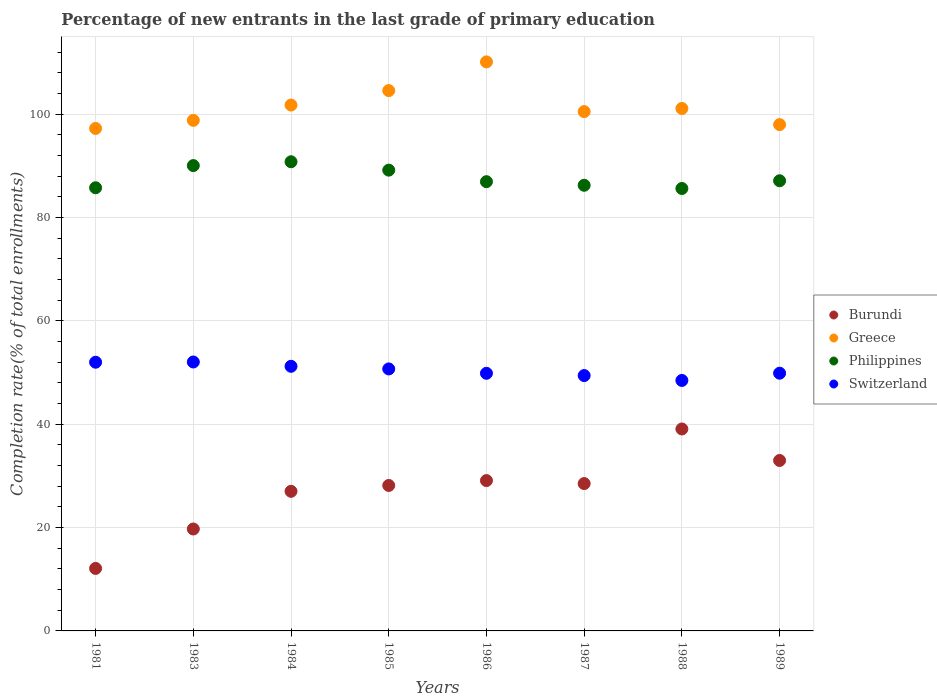Is the number of dotlines equal to the number of legend labels?
Keep it short and to the point. Yes. What is the percentage of new entrants in Philippines in 1985?
Keep it short and to the point. 89.16. Across all years, what is the maximum percentage of new entrants in Burundi?
Make the answer very short. 39.08. Across all years, what is the minimum percentage of new entrants in Philippines?
Provide a short and direct response. 85.61. In which year was the percentage of new entrants in Burundi minimum?
Ensure brevity in your answer.  1981. What is the total percentage of new entrants in Philippines in the graph?
Your answer should be very brief. 701.64. What is the difference between the percentage of new entrants in Switzerland in 1984 and that in 1986?
Provide a short and direct response. 1.35. What is the difference between the percentage of new entrants in Greece in 1985 and the percentage of new entrants in Philippines in 1987?
Your response must be concise. 18.32. What is the average percentage of new entrants in Burundi per year?
Your answer should be compact. 27.08. In the year 1988, what is the difference between the percentage of new entrants in Greece and percentage of new entrants in Philippines?
Provide a succinct answer. 15.48. What is the ratio of the percentage of new entrants in Greece in 1985 to that in 1987?
Provide a short and direct response. 1.04. Is the difference between the percentage of new entrants in Greece in 1984 and 1985 greater than the difference between the percentage of new entrants in Philippines in 1984 and 1985?
Your answer should be very brief. No. What is the difference between the highest and the second highest percentage of new entrants in Burundi?
Provide a succinct answer. 6.09. What is the difference between the highest and the lowest percentage of new entrants in Philippines?
Keep it short and to the point. 5.17. In how many years, is the percentage of new entrants in Philippines greater than the average percentage of new entrants in Philippines taken over all years?
Offer a terse response. 3. Is the sum of the percentage of new entrants in Greece in 1983 and 1989 greater than the maximum percentage of new entrants in Switzerland across all years?
Your response must be concise. Yes. Is it the case that in every year, the sum of the percentage of new entrants in Philippines and percentage of new entrants in Switzerland  is greater than the sum of percentage of new entrants in Greece and percentage of new entrants in Burundi?
Your response must be concise. No. Is it the case that in every year, the sum of the percentage of new entrants in Burundi and percentage of new entrants in Switzerland  is greater than the percentage of new entrants in Philippines?
Provide a succinct answer. No. Does the percentage of new entrants in Switzerland monotonically increase over the years?
Ensure brevity in your answer.  No. What is the difference between two consecutive major ticks on the Y-axis?
Provide a short and direct response. 20. Are the values on the major ticks of Y-axis written in scientific E-notation?
Keep it short and to the point. No. Does the graph contain grids?
Offer a very short reply. Yes. Where does the legend appear in the graph?
Provide a succinct answer. Center right. How many legend labels are there?
Your response must be concise. 4. How are the legend labels stacked?
Ensure brevity in your answer.  Vertical. What is the title of the graph?
Keep it short and to the point. Percentage of new entrants in the last grade of primary education. Does "Honduras" appear as one of the legend labels in the graph?
Provide a succinct answer. No. What is the label or title of the Y-axis?
Your response must be concise. Completion rate(% of total enrollments). What is the Completion rate(% of total enrollments) of Burundi in 1981?
Provide a succinct answer. 12.09. What is the Completion rate(% of total enrollments) of Greece in 1981?
Offer a very short reply. 97.23. What is the Completion rate(% of total enrollments) of Philippines in 1981?
Keep it short and to the point. 85.75. What is the Completion rate(% of total enrollments) in Switzerland in 1981?
Offer a very short reply. 52. What is the Completion rate(% of total enrollments) of Burundi in 1983?
Your answer should be compact. 19.72. What is the Completion rate(% of total enrollments) in Greece in 1983?
Keep it short and to the point. 98.8. What is the Completion rate(% of total enrollments) in Philippines in 1983?
Give a very brief answer. 90.04. What is the Completion rate(% of total enrollments) of Switzerland in 1983?
Keep it short and to the point. 52.04. What is the Completion rate(% of total enrollments) in Burundi in 1984?
Offer a terse response. 27.01. What is the Completion rate(% of total enrollments) in Greece in 1984?
Your answer should be very brief. 101.76. What is the Completion rate(% of total enrollments) in Philippines in 1984?
Provide a short and direct response. 90.79. What is the Completion rate(% of total enrollments) of Switzerland in 1984?
Provide a short and direct response. 51.21. What is the Completion rate(% of total enrollments) in Burundi in 1985?
Provide a succinct answer. 28.15. What is the Completion rate(% of total enrollments) of Greece in 1985?
Make the answer very short. 104.56. What is the Completion rate(% of total enrollments) in Philippines in 1985?
Your answer should be very brief. 89.16. What is the Completion rate(% of total enrollments) in Switzerland in 1985?
Offer a very short reply. 50.7. What is the Completion rate(% of total enrollments) in Burundi in 1986?
Your response must be concise. 29.09. What is the Completion rate(% of total enrollments) in Greece in 1986?
Give a very brief answer. 110.11. What is the Completion rate(% of total enrollments) of Philippines in 1986?
Your answer should be very brief. 86.93. What is the Completion rate(% of total enrollments) of Switzerland in 1986?
Keep it short and to the point. 49.85. What is the Completion rate(% of total enrollments) in Burundi in 1987?
Offer a very short reply. 28.51. What is the Completion rate(% of total enrollments) of Greece in 1987?
Offer a terse response. 100.49. What is the Completion rate(% of total enrollments) of Philippines in 1987?
Your answer should be very brief. 86.24. What is the Completion rate(% of total enrollments) in Switzerland in 1987?
Keep it short and to the point. 49.42. What is the Completion rate(% of total enrollments) in Burundi in 1988?
Offer a very short reply. 39.08. What is the Completion rate(% of total enrollments) of Greece in 1988?
Your answer should be very brief. 101.1. What is the Completion rate(% of total enrollments) in Philippines in 1988?
Provide a succinct answer. 85.61. What is the Completion rate(% of total enrollments) of Switzerland in 1988?
Provide a succinct answer. 48.47. What is the Completion rate(% of total enrollments) in Burundi in 1989?
Provide a short and direct response. 32.98. What is the Completion rate(% of total enrollments) of Greece in 1989?
Your response must be concise. 97.98. What is the Completion rate(% of total enrollments) in Philippines in 1989?
Your answer should be very brief. 87.11. What is the Completion rate(% of total enrollments) of Switzerland in 1989?
Offer a very short reply. 49.87. Across all years, what is the maximum Completion rate(% of total enrollments) in Burundi?
Provide a short and direct response. 39.08. Across all years, what is the maximum Completion rate(% of total enrollments) of Greece?
Make the answer very short. 110.11. Across all years, what is the maximum Completion rate(% of total enrollments) of Philippines?
Offer a very short reply. 90.79. Across all years, what is the maximum Completion rate(% of total enrollments) in Switzerland?
Ensure brevity in your answer.  52.04. Across all years, what is the minimum Completion rate(% of total enrollments) in Burundi?
Give a very brief answer. 12.09. Across all years, what is the minimum Completion rate(% of total enrollments) of Greece?
Your response must be concise. 97.23. Across all years, what is the minimum Completion rate(% of total enrollments) of Philippines?
Ensure brevity in your answer.  85.61. Across all years, what is the minimum Completion rate(% of total enrollments) of Switzerland?
Your answer should be compact. 48.47. What is the total Completion rate(% of total enrollments) in Burundi in the graph?
Your response must be concise. 216.65. What is the total Completion rate(% of total enrollments) of Greece in the graph?
Offer a very short reply. 812.02. What is the total Completion rate(% of total enrollments) of Philippines in the graph?
Offer a very short reply. 701.64. What is the total Completion rate(% of total enrollments) of Switzerland in the graph?
Your answer should be compact. 403.55. What is the difference between the Completion rate(% of total enrollments) in Burundi in 1981 and that in 1983?
Make the answer very short. -7.63. What is the difference between the Completion rate(% of total enrollments) in Greece in 1981 and that in 1983?
Give a very brief answer. -1.56. What is the difference between the Completion rate(% of total enrollments) in Philippines in 1981 and that in 1983?
Provide a succinct answer. -4.29. What is the difference between the Completion rate(% of total enrollments) of Switzerland in 1981 and that in 1983?
Your response must be concise. -0.04. What is the difference between the Completion rate(% of total enrollments) of Burundi in 1981 and that in 1984?
Offer a terse response. -14.92. What is the difference between the Completion rate(% of total enrollments) in Greece in 1981 and that in 1984?
Keep it short and to the point. -4.53. What is the difference between the Completion rate(% of total enrollments) of Philippines in 1981 and that in 1984?
Your answer should be compact. -5.03. What is the difference between the Completion rate(% of total enrollments) in Switzerland in 1981 and that in 1984?
Make the answer very short. 0.79. What is the difference between the Completion rate(% of total enrollments) of Burundi in 1981 and that in 1985?
Your response must be concise. -16.05. What is the difference between the Completion rate(% of total enrollments) of Greece in 1981 and that in 1985?
Offer a terse response. -7.32. What is the difference between the Completion rate(% of total enrollments) in Philippines in 1981 and that in 1985?
Offer a very short reply. -3.41. What is the difference between the Completion rate(% of total enrollments) in Switzerland in 1981 and that in 1985?
Keep it short and to the point. 1.3. What is the difference between the Completion rate(% of total enrollments) in Burundi in 1981 and that in 1986?
Ensure brevity in your answer.  -17. What is the difference between the Completion rate(% of total enrollments) of Greece in 1981 and that in 1986?
Offer a very short reply. -12.88. What is the difference between the Completion rate(% of total enrollments) of Philippines in 1981 and that in 1986?
Your answer should be compact. -1.18. What is the difference between the Completion rate(% of total enrollments) in Switzerland in 1981 and that in 1986?
Ensure brevity in your answer.  2.14. What is the difference between the Completion rate(% of total enrollments) in Burundi in 1981 and that in 1987?
Provide a succinct answer. -16.42. What is the difference between the Completion rate(% of total enrollments) in Greece in 1981 and that in 1987?
Provide a short and direct response. -3.26. What is the difference between the Completion rate(% of total enrollments) in Philippines in 1981 and that in 1987?
Your answer should be very brief. -0.48. What is the difference between the Completion rate(% of total enrollments) of Switzerland in 1981 and that in 1987?
Offer a terse response. 2.58. What is the difference between the Completion rate(% of total enrollments) in Burundi in 1981 and that in 1988?
Provide a succinct answer. -26.98. What is the difference between the Completion rate(% of total enrollments) of Greece in 1981 and that in 1988?
Your response must be concise. -3.86. What is the difference between the Completion rate(% of total enrollments) in Philippines in 1981 and that in 1988?
Your response must be concise. 0.14. What is the difference between the Completion rate(% of total enrollments) in Switzerland in 1981 and that in 1988?
Offer a terse response. 3.53. What is the difference between the Completion rate(% of total enrollments) of Burundi in 1981 and that in 1989?
Your answer should be very brief. -20.89. What is the difference between the Completion rate(% of total enrollments) in Greece in 1981 and that in 1989?
Ensure brevity in your answer.  -0.74. What is the difference between the Completion rate(% of total enrollments) of Philippines in 1981 and that in 1989?
Provide a short and direct response. -1.36. What is the difference between the Completion rate(% of total enrollments) in Switzerland in 1981 and that in 1989?
Ensure brevity in your answer.  2.13. What is the difference between the Completion rate(% of total enrollments) in Burundi in 1983 and that in 1984?
Your answer should be compact. -7.29. What is the difference between the Completion rate(% of total enrollments) in Greece in 1983 and that in 1984?
Offer a terse response. -2.96. What is the difference between the Completion rate(% of total enrollments) in Philippines in 1983 and that in 1984?
Your answer should be very brief. -0.74. What is the difference between the Completion rate(% of total enrollments) in Switzerland in 1983 and that in 1984?
Your answer should be compact. 0.83. What is the difference between the Completion rate(% of total enrollments) in Burundi in 1983 and that in 1985?
Keep it short and to the point. -8.42. What is the difference between the Completion rate(% of total enrollments) of Greece in 1983 and that in 1985?
Offer a very short reply. -5.76. What is the difference between the Completion rate(% of total enrollments) in Philippines in 1983 and that in 1985?
Your answer should be compact. 0.88. What is the difference between the Completion rate(% of total enrollments) in Switzerland in 1983 and that in 1985?
Offer a very short reply. 1.34. What is the difference between the Completion rate(% of total enrollments) of Burundi in 1983 and that in 1986?
Provide a succinct answer. -9.37. What is the difference between the Completion rate(% of total enrollments) in Greece in 1983 and that in 1986?
Provide a succinct answer. -11.31. What is the difference between the Completion rate(% of total enrollments) in Philippines in 1983 and that in 1986?
Offer a very short reply. 3.11. What is the difference between the Completion rate(% of total enrollments) of Switzerland in 1983 and that in 1986?
Ensure brevity in your answer.  2.19. What is the difference between the Completion rate(% of total enrollments) of Burundi in 1983 and that in 1987?
Make the answer very short. -8.79. What is the difference between the Completion rate(% of total enrollments) in Greece in 1983 and that in 1987?
Keep it short and to the point. -1.7. What is the difference between the Completion rate(% of total enrollments) of Philippines in 1983 and that in 1987?
Provide a short and direct response. 3.81. What is the difference between the Completion rate(% of total enrollments) of Switzerland in 1983 and that in 1987?
Keep it short and to the point. 2.62. What is the difference between the Completion rate(% of total enrollments) in Burundi in 1983 and that in 1988?
Offer a very short reply. -19.36. What is the difference between the Completion rate(% of total enrollments) of Greece in 1983 and that in 1988?
Ensure brevity in your answer.  -2.3. What is the difference between the Completion rate(% of total enrollments) in Philippines in 1983 and that in 1988?
Give a very brief answer. 4.43. What is the difference between the Completion rate(% of total enrollments) of Switzerland in 1983 and that in 1988?
Provide a succinct answer. 3.57. What is the difference between the Completion rate(% of total enrollments) in Burundi in 1983 and that in 1989?
Your answer should be very brief. -13.26. What is the difference between the Completion rate(% of total enrollments) in Greece in 1983 and that in 1989?
Ensure brevity in your answer.  0.82. What is the difference between the Completion rate(% of total enrollments) of Philippines in 1983 and that in 1989?
Give a very brief answer. 2.93. What is the difference between the Completion rate(% of total enrollments) of Switzerland in 1983 and that in 1989?
Give a very brief answer. 2.17. What is the difference between the Completion rate(% of total enrollments) of Burundi in 1984 and that in 1985?
Ensure brevity in your answer.  -1.13. What is the difference between the Completion rate(% of total enrollments) of Greece in 1984 and that in 1985?
Keep it short and to the point. -2.8. What is the difference between the Completion rate(% of total enrollments) in Philippines in 1984 and that in 1985?
Your answer should be very brief. 1.62. What is the difference between the Completion rate(% of total enrollments) of Switzerland in 1984 and that in 1985?
Your answer should be compact. 0.51. What is the difference between the Completion rate(% of total enrollments) of Burundi in 1984 and that in 1986?
Offer a very short reply. -2.08. What is the difference between the Completion rate(% of total enrollments) of Greece in 1984 and that in 1986?
Your answer should be very brief. -8.35. What is the difference between the Completion rate(% of total enrollments) of Philippines in 1984 and that in 1986?
Your answer should be very brief. 3.85. What is the difference between the Completion rate(% of total enrollments) in Switzerland in 1984 and that in 1986?
Make the answer very short. 1.35. What is the difference between the Completion rate(% of total enrollments) of Burundi in 1984 and that in 1987?
Provide a short and direct response. -1.5. What is the difference between the Completion rate(% of total enrollments) in Greece in 1984 and that in 1987?
Make the answer very short. 1.27. What is the difference between the Completion rate(% of total enrollments) in Philippines in 1984 and that in 1987?
Your answer should be very brief. 4.55. What is the difference between the Completion rate(% of total enrollments) of Switzerland in 1984 and that in 1987?
Give a very brief answer. 1.79. What is the difference between the Completion rate(% of total enrollments) of Burundi in 1984 and that in 1988?
Ensure brevity in your answer.  -12.06. What is the difference between the Completion rate(% of total enrollments) of Greece in 1984 and that in 1988?
Provide a short and direct response. 0.66. What is the difference between the Completion rate(% of total enrollments) of Philippines in 1984 and that in 1988?
Provide a succinct answer. 5.17. What is the difference between the Completion rate(% of total enrollments) of Switzerland in 1984 and that in 1988?
Your answer should be compact. 2.74. What is the difference between the Completion rate(% of total enrollments) in Burundi in 1984 and that in 1989?
Your answer should be very brief. -5.97. What is the difference between the Completion rate(% of total enrollments) of Greece in 1984 and that in 1989?
Your response must be concise. 3.78. What is the difference between the Completion rate(% of total enrollments) in Philippines in 1984 and that in 1989?
Ensure brevity in your answer.  3.68. What is the difference between the Completion rate(% of total enrollments) of Switzerland in 1984 and that in 1989?
Your answer should be very brief. 1.34. What is the difference between the Completion rate(% of total enrollments) in Burundi in 1985 and that in 1986?
Keep it short and to the point. -0.94. What is the difference between the Completion rate(% of total enrollments) of Greece in 1985 and that in 1986?
Offer a very short reply. -5.55. What is the difference between the Completion rate(% of total enrollments) in Philippines in 1985 and that in 1986?
Keep it short and to the point. 2.23. What is the difference between the Completion rate(% of total enrollments) in Switzerland in 1985 and that in 1986?
Provide a short and direct response. 0.85. What is the difference between the Completion rate(% of total enrollments) of Burundi in 1985 and that in 1987?
Your answer should be very brief. -0.37. What is the difference between the Completion rate(% of total enrollments) in Greece in 1985 and that in 1987?
Make the answer very short. 4.06. What is the difference between the Completion rate(% of total enrollments) in Philippines in 1985 and that in 1987?
Provide a short and direct response. 2.93. What is the difference between the Completion rate(% of total enrollments) in Switzerland in 1985 and that in 1987?
Give a very brief answer. 1.28. What is the difference between the Completion rate(% of total enrollments) of Burundi in 1985 and that in 1988?
Provide a short and direct response. -10.93. What is the difference between the Completion rate(% of total enrollments) of Greece in 1985 and that in 1988?
Give a very brief answer. 3.46. What is the difference between the Completion rate(% of total enrollments) of Philippines in 1985 and that in 1988?
Your answer should be compact. 3.55. What is the difference between the Completion rate(% of total enrollments) of Switzerland in 1985 and that in 1988?
Give a very brief answer. 2.23. What is the difference between the Completion rate(% of total enrollments) in Burundi in 1985 and that in 1989?
Offer a terse response. -4.84. What is the difference between the Completion rate(% of total enrollments) of Greece in 1985 and that in 1989?
Ensure brevity in your answer.  6.58. What is the difference between the Completion rate(% of total enrollments) in Philippines in 1985 and that in 1989?
Your answer should be compact. 2.05. What is the difference between the Completion rate(% of total enrollments) in Switzerland in 1985 and that in 1989?
Offer a terse response. 0.83. What is the difference between the Completion rate(% of total enrollments) of Burundi in 1986 and that in 1987?
Give a very brief answer. 0.58. What is the difference between the Completion rate(% of total enrollments) in Greece in 1986 and that in 1987?
Your answer should be compact. 9.62. What is the difference between the Completion rate(% of total enrollments) in Philippines in 1986 and that in 1987?
Your answer should be very brief. 0.7. What is the difference between the Completion rate(% of total enrollments) in Switzerland in 1986 and that in 1987?
Give a very brief answer. 0.44. What is the difference between the Completion rate(% of total enrollments) of Burundi in 1986 and that in 1988?
Your answer should be very brief. -9.99. What is the difference between the Completion rate(% of total enrollments) of Greece in 1986 and that in 1988?
Offer a very short reply. 9.01. What is the difference between the Completion rate(% of total enrollments) in Philippines in 1986 and that in 1988?
Ensure brevity in your answer.  1.32. What is the difference between the Completion rate(% of total enrollments) in Switzerland in 1986 and that in 1988?
Your answer should be compact. 1.38. What is the difference between the Completion rate(% of total enrollments) in Burundi in 1986 and that in 1989?
Keep it short and to the point. -3.89. What is the difference between the Completion rate(% of total enrollments) in Greece in 1986 and that in 1989?
Your answer should be compact. 12.13. What is the difference between the Completion rate(% of total enrollments) in Philippines in 1986 and that in 1989?
Give a very brief answer. -0.18. What is the difference between the Completion rate(% of total enrollments) in Switzerland in 1986 and that in 1989?
Make the answer very short. -0.02. What is the difference between the Completion rate(% of total enrollments) in Burundi in 1987 and that in 1988?
Provide a short and direct response. -10.57. What is the difference between the Completion rate(% of total enrollments) in Greece in 1987 and that in 1988?
Your answer should be compact. -0.6. What is the difference between the Completion rate(% of total enrollments) of Philippines in 1987 and that in 1988?
Offer a very short reply. 0.62. What is the difference between the Completion rate(% of total enrollments) in Switzerland in 1987 and that in 1988?
Make the answer very short. 0.95. What is the difference between the Completion rate(% of total enrollments) of Burundi in 1987 and that in 1989?
Offer a terse response. -4.47. What is the difference between the Completion rate(% of total enrollments) of Greece in 1987 and that in 1989?
Offer a terse response. 2.52. What is the difference between the Completion rate(% of total enrollments) of Philippines in 1987 and that in 1989?
Ensure brevity in your answer.  -0.87. What is the difference between the Completion rate(% of total enrollments) in Switzerland in 1987 and that in 1989?
Make the answer very short. -0.45. What is the difference between the Completion rate(% of total enrollments) of Burundi in 1988 and that in 1989?
Provide a succinct answer. 6.09. What is the difference between the Completion rate(% of total enrollments) of Greece in 1988 and that in 1989?
Offer a terse response. 3.12. What is the difference between the Completion rate(% of total enrollments) of Philippines in 1988 and that in 1989?
Keep it short and to the point. -1.5. What is the difference between the Completion rate(% of total enrollments) of Switzerland in 1988 and that in 1989?
Your response must be concise. -1.4. What is the difference between the Completion rate(% of total enrollments) of Burundi in 1981 and the Completion rate(% of total enrollments) of Greece in 1983?
Ensure brevity in your answer.  -86.7. What is the difference between the Completion rate(% of total enrollments) of Burundi in 1981 and the Completion rate(% of total enrollments) of Philippines in 1983?
Make the answer very short. -77.95. What is the difference between the Completion rate(% of total enrollments) of Burundi in 1981 and the Completion rate(% of total enrollments) of Switzerland in 1983?
Ensure brevity in your answer.  -39.94. What is the difference between the Completion rate(% of total enrollments) in Greece in 1981 and the Completion rate(% of total enrollments) in Philippines in 1983?
Make the answer very short. 7.19. What is the difference between the Completion rate(% of total enrollments) in Greece in 1981 and the Completion rate(% of total enrollments) in Switzerland in 1983?
Give a very brief answer. 45.19. What is the difference between the Completion rate(% of total enrollments) in Philippines in 1981 and the Completion rate(% of total enrollments) in Switzerland in 1983?
Provide a succinct answer. 33.71. What is the difference between the Completion rate(% of total enrollments) in Burundi in 1981 and the Completion rate(% of total enrollments) in Greece in 1984?
Offer a very short reply. -89.66. What is the difference between the Completion rate(% of total enrollments) of Burundi in 1981 and the Completion rate(% of total enrollments) of Philippines in 1984?
Your response must be concise. -78.69. What is the difference between the Completion rate(% of total enrollments) in Burundi in 1981 and the Completion rate(% of total enrollments) in Switzerland in 1984?
Your answer should be compact. -39.11. What is the difference between the Completion rate(% of total enrollments) in Greece in 1981 and the Completion rate(% of total enrollments) in Philippines in 1984?
Offer a very short reply. 6.45. What is the difference between the Completion rate(% of total enrollments) in Greece in 1981 and the Completion rate(% of total enrollments) in Switzerland in 1984?
Provide a succinct answer. 46.03. What is the difference between the Completion rate(% of total enrollments) of Philippines in 1981 and the Completion rate(% of total enrollments) of Switzerland in 1984?
Your response must be concise. 34.55. What is the difference between the Completion rate(% of total enrollments) in Burundi in 1981 and the Completion rate(% of total enrollments) in Greece in 1985?
Your response must be concise. -92.46. What is the difference between the Completion rate(% of total enrollments) in Burundi in 1981 and the Completion rate(% of total enrollments) in Philippines in 1985?
Keep it short and to the point. -77.07. What is the difference between the Completion rate(% of total enrollments) in Burundi in 1981 and the Completion rate(% of total enrollments) in Switzerland in 1985?
Offer a terse response. -38.6. What is the difference between the Completion rate(% of total enrollments) of Greece in 1981 and the Completion rate(% of total enrollments) of Philippines in 1985?
Keep it short and to the point. 8.07. What is the difference between the Completion rate(% of total enrollments) of Greece in 1981 and the Completion rate(% of total enrollments) of Switzerland in 1985?
Keep it short and to the point. 46.53. What is the difference between the Completion rate(% of total enrollments) in Philippines in 1981 and the Completion rate(% of total enrollments) in Switzerland in 1985?
Your response must be concise. 35.05. What is the difference between the Completion rate(% of total enrollments) of Burundi in 1981 and the Completion rate(% of total enrollments) of Greece in 1986?
Your answer should be very brief. -98.01. What is the difference between the Completion rate(% of total enrollments) of Burundi in 1981 and the Completion rate(% of total enrollments) of Philippines in 1986?
Offer a terse response. -74.84. What is the difference between the Completion rate(% of total enrollments) of Burundi in 1981 and the Completion rate(% of total enrollments) of Switzerland in 1986?
Ensure brevity in your answer.  -37.76. What is the difference between the Completion rate(% of total enrollments) of Greece in 1981 and the Completion rate(% of total enrollments) of Philippines in 1986?
Make the answer very short. 10.3. What is the difference between the Completion rate(% of total enrollments) of Greece in 1981 and the Completion rate(% of total enrollments) of Switzerland in 1986?
Your response must be concise. 47.38. What is the difference between the Completion rate(% of total enrollments) of Philippines in 1981 and the Completion rate(% of total enrollments) of Switzerland in 1986?
Offer a very short reply. 35.9. What is the difference between the Completion rate(% of total enrollments) in Burundi in 1981 and the Completion rate(% of total enrollments) in Greece in 1987?
Provide a succinct answer. -88.4. What is the difference between the Completion rate(% of total enrollments) in Burundi in 1981 and the Completion rate(% of total enrollments) in Philippines in 1987?
Provide a short and direct response. -74.14. What is the difference between the Completion rate(% of total enrollments) in Burundi in 1981 and the Completion rate(% of total enrollments) in Switzerland in 1987?
Your response must be concise. -37.32. What is the difference between the Completion rate(% of total enrollments) in Greece in 1981 and the Completion rate(% of total enrollments) in Philippines in 1987?
Keep it short and to the point. 11. What is the difference between the Completion rate(% of total enrollments) in Greece in 1981 and the Completion rate(% of total enrollments) in Switzerland in 1987?
Offer a terse response. 47.82. What is the difference between the Completion rate(% of total enrollments) in Philippines in 1981 and the Completion rate(% of total enrollments) in Switzerland in 1987?
Give a very brief answer. 36.34. What is the difference between the Completion rate(% of total enrollments) in Burundi in 1981 and the Completion rate(% of total enrollments) in Greece in 1988?
Keep it short and to the point. -89. What is the difference between the Completion rate(% of total enrollments) of Burundi in 1981 and the Completion rate(% of total enrollments) of Philippines in 1988?
Make the answer very short. -73.52. What is the difference between the Completion rate(% of total enrollments) of Burundi in 1981 and the Completion rate(% of total enrollments) of Switzerland in 1988?
Your response must be concise. -36.37. What is the difference between the Completion rate(% of total enrollments) of Greece in 1981 and the Completion rate(% of total enrollments) of Philippines in 1988?
Ensure brevity in your answer.  11.62. What is the difference between the Completion rate(% of total enrollments) in Greece in 1981 and the Completion rate(% of total enrollments) in Switzerland in 1988?
Your response must be concise. 48.76. What is the difference between the Completion rate(% of total enrollments) in Philippines in 1981 and the Completion rate(% of total enrollments) in Switzerland in 1988?
Give a very brief answer. 37.28. What is the difference between the Completion rate(% of total enrollments) of Burundi in 1981 and the Completion rate(% of total enrollments) of Greece in 1989?
Make the answer very short. -85.88. What is the difference between the Completion rate(% of total enrollments) of Burundi in 1981 and the Completion rate(% of total enrollments) of Philippines in 1989?
Ensure brevity in your answer.  -75.01. What is the difference between the Completion rate(% of total enrollments) in Burundi in 1981 and the Completion rate(% of total enrollments) in Switzerland in 1989?
Make the answer very short. -37.77. What is the difference between the Completion rate(% of total enrollments) in Greece in 1981 and the Completion rate(% of total enrollments) in Philippines in 1989?
Keep it short and to the point. 10.12. What is the difference between the Completion rate(% of total enrollments) of Greece in 1981 and the Completion rate(% of total enrollments) of Switzerland in 1989?
Provide a succinct answer. 47.36. What is the difference between the Completion rate(% of total enrollments) in Philippines in 1981 and the Completion rate(% of total enrollments) in Switzerland in 1989?
Provide a succinct answer. 35.88. What is the difference between the Completion rate(% of total enrollments) in Burundi in 1983 and the Completion rate(% of total enrollments) in Greece in 1984?
Provide a succinct answer. -82.04. What is the difference between the Completion rate(% of total enrollments) in Burundi in 1983 and the Completion rate(% of total enrollments) in Philippines in 1984?
Ensure brevity in your answer.  -71.06. What is the difference between the Completion rate(% of total enrollments) in Burundi in 1983 and the Completion rate(% of total enrollments) in Switzerland in 1984?
Ensure brevity in your answer.  -31.48. What is the difference between the Completion rate(% of total enrollments) in Greece in 1983 and the Completion rate(% of total enrollments) in Philippines in 1984?
Offer a terse response. 8.01. What is the difference between the Completion rate(% of total enrollments) in Greece in 1983 and the Completion rate(% of total enrollments) in Switzerland in 1984?
Your answer should be very brief. 47.59. What is the difference between the Completion rate(% of total enrollments) in Philippines in 1983 and the Completion rate(% of total enrollments) in Switzerland in 1984?
Your response must be concise. 38.84. What is the difference between the Completion rate(% of total enrollments) of Burundi in 1983 and the Completion rate(% of total enrollments) of Greece in 1985?
Your answer should be compact. -84.83. What is the difference between the Completion rate(% of total enrollments) of Burundi in 1983 and the Completion rate(% of total enrollments) of Philippines in 1985?
Provide a short and direct response. -69.44. What is the difference between the Completion rate(% of total enrollments) of Burundi in 1983 and the Completion rate(% of total enrollments) of Switzerland in 1985?
Make the answer very short. -30.97. What is the difference between the Completion rate(% of total enrollments) of Greece in 1983 and the Completion rate(% of total enrollments) of Philippines in 1985?
Your answer should be very brief. 9.63. What is the difference between the Completion rate(% of total enrollments) in Greece in 1983 and the Completion rate(% of total enrollments) in Switzerland in 1985?
Keep it short and to the point. 48.1. What is the difference between the Completion rate(% of total enrollments) in Philippines in 1983 and the Completion rate(% of total enrollments) in Switzerland in 1985?
Make the answer very short. 39.35. What is the difference between the Completion rate(% of total enrollments) in Burundi in 1983 and the Completion rate(% of total enrollments) in Greece in 1986?
Offer a very short reply. -90.39. What is the difference between the Completion rate(% of total enrollments) in Burundi in 1983 and the Completion rate(% of total enrollments) in Philippines in 1986?
Make the answer very short. -67.21. What is the difference between the Completion rate(% of total enrollments) of Burundi in 1983 and the Completion rate(% of total enrollments) of Switzerland in 1986?
Make the answer very short. -30.13. What is the difference between the Completion rate(% of total enrollments) in Greece in 1983 and the Completion rate(% of total enrollments) in Philippines in 1986?
Make the answer very short. 11.86. What is the difference between the Completion rate(% of total enrollments) of Greece in 1983 and the Completion rate(% of total enrollments) of Switzerland in 1986?
Offer a very short reply. 48.94. What is the difference between the Completion rate(% of total enrollments) of Philippines in 1983 and the Completion rate(% of total enrollments) of Switzerland in 1986?
Provide a short and direct response. 40.19. What is the difference between the Completion rate(% of total enrollments) of Burundi in 1983 and the Completion rate(% of total enrollments) of Greece in 1987?
Your answer should be very brief. -80.77. What is the difference between the Completion rate(% of total enrollments) of Burundi in 1983 and the Completion rate(% of total enrollments) of Philippines in 1987?
Provide a short and direct response. -66.51. What is the difference between the Completion rate(% of total enrollments) of Burundi in 1983 and the Completion rate(% of total enrollments) of Switzerland in 1987?
Ensure brevity in your answer.  -29.69. What is the difference between the Completion rate(% of total enrollments) of Greece in 1983 and the Completion rate(% of total enrollments) of Philippines in 1987?
Offer a very short reply. 12.56. What is the difference between the Completion rate(% of total enrollments) of Greece in 1983 and the Completion rate(% of total enrollments) of Switzerland in 1987?
Your response must be concise. 49.38. What is the difference between the Completion rate(% of total enrollments) of Philippines in 1983 and the Completion rate(% of total enrollments) of Switzerland in 1987?
Make the answer very short. 40.63. What is the difference between the Completion rate(% of total enrollments) of Burundi in 1983 and the Completion rate(% of total enrollments) of Greece in 1988?
Offer a very short reply. -81.37. What is the difference between the Completion rate(% of total enrollments) in Burundi in 1983 and the Completion rate(% of total enrollments) in Philippines in 1988?
Your answer should be very brief. -65.89. What is the difference between the Completion rate(% of total enrollments) in Burundi in 1983 and the Completion rate(% of total enrollments) in Switzerland in 1988?
Make the answer very short. -28.75. What is the difference between the Completion rate(% of total enrollments) in Greece in 1983 and the Completion rate(% of total enrollments) in Philippines in 1988?
Keep it short and to the point. 13.18. What is the difference between the Completion rate(% of total enrollments) in Greece in 1983 and the Completion rate(% of total enrollments) in Switzerland in 1988?
Your response must be concise. 50.33. What is the difference between the Completion rate(% of total enrollments) of Philippines in 1983 and the Completion rate(% of total enrollments) of Switzerland in 1988?
Provide a succinct answer. 41.57. What is the difference between the Completion rate(% of total enrollments) in Burundi in 1983 and the Completion rate(% of total enrollments) in Greece in 1989?
Ensure brevity in your answer.  -78.25. What is the difference between the Completion rate(% of total enrollments) of Burundi in 1983 and the Completion rate(% of total enrollments) of Philippines in 1989?
Give a very brief answer. -67.39. What is the difference between the Completion rate(% of total enrollments) in Burundi in 1983 and the Completion rate(% of total enrollments) in Switzerland in 1989?
Offer a very short reply. -30.15. What is the difference between the Completion rate(% of total enrollments) of Greece in 1983 and the Completion rate(% of total enrollments) of Philippines in 1989?
Offer a very short reply. 11.69. What is the difference between the Completion rate(% of total enrollments) in Greece in 1983 and the Completion rate(% of total enrollments) in Switzerland in 1989?
Your answer should be compact. 48.93. What is the difference between the Completion rate(% of total enrollments) in Philippines in 1983 and the Completion rate(% of total enrollments) in Switzerland in 1989?
Offer a very short reply. 40.17. What is the difference between the Completion rate(% of total enrollments) in Burundi in 1984 and the Completion rate(% of total enrollments) in Greece in 1985?
Keep it short and to the point. -77.54. What is the difference between the Completion rate(% of total enrollments) of Burundi in 1984 and the Completion rate(% of total enrollments) of Philippines in 1985?
Keep it short and to the point. -62.15. What is the difference between the Completion rate(% of total enrollments) of Burundi in 1984 and the Completion rate(% of total enrollments) of Switzerland in 1985?
Your response must be concise. -23.68. What is the difference between the Completion rate(% of total enrollments) in Greece in 1984 and the Completion rate(% of total enrollments) in Philippines in 1985?
Your answer should be compact. 12.59. What is the difference between the Completion rate(% of total enrollments) in Greece in 1984 and the Completion rate(% of total enrollments) in Switzerland in 1985?
Offer a terse response. 51.06. What is the difference between the Completion rate(% of total enrollments) in Philippines in 1984 and the Completion rate(% of total enrollments) in Switzerland in 1985?
Offer a terse response. 40.09. What is the difference between the Completion rate(% of total enrollments) of Burundi in 1984 and the Completion rate(% of total enrollments) of Greece in 1986?
Your answer should be very brief. -83.1. What is the difference between the Completion rate(% of total enrollments) in Burundi in 1984 and the Completion rate(% of total enrollments) in Philippines in 1986?
Offer a very short reply. -59.92. What is the difference between the Completion rate(% of total enrollments) of Burundi in 1984 and the Completion rate(% of total enrollments) of Switzerland in 1986?
Offer a very short reply. -22.84. What is the difference between the Completion rate(% of total enrollments) in Greece in 1984 and the Completion rate(% of total enrollments) in Philippines in 1986?
Your answer should be compact. 14.83. What is the difference between the Completion rate(% of total enrollments) in Greece in 1984 and the Completion rate(% of total enrollments) in Switzerland in 1986?
Provide a short and direct response. 51.91. What is the difference between the Completion rate(% of total enrollments) in Philippines in 1984 and the Completion rate(% of total enrollments) in Switzerland in 1986?
Make the answer very short. 40.93. What is the difference between the Completion rate(% of total enrollments) of Burundi in 1984 and the Completion rate(% of total enrollments) of Greece in 1987?
Give a very brief answer. -73.48. What is the difference between the Completion rate(% of total enrollments) in Burundi in 1984 and the Completion rate(% of total enrollments) in Philippines in 1987?
Your response must be concise. -59.22. What is the difference between the Completion rate(% of total enrollments) of Burundi in 1984 and the Completion rate(% of total enrollments) of Switzerland in 1987?
Offer a very short reply. -22.4. What is the difference between the Completion rate(% of total enrollments) of Greece in 1984 and the Completion rate(% of total enrollments) of Philippines in 1987?
Your answer should be very brief. 15.52. What is the difference between the Completion rate(% of total enrollments) of Greece in 1984 and the Completion rate(% of total enrollments) of Switzerland in 1987?
Keep it short and to the point. 52.34. What is the difference between the Completion rate(% of total enrollments) in Philippines in 1984 and the Completion rate(% of total enrollments) in Switzerland in 1987?
Give a very brief answer. 41.37. What is the difference between the Completion rate(% of total enrollments) in Burundi in 1984 and the Completion rate(% of total enrollments) in Greece in 1988?
Ensure brevity in your answer.  -74.08. What is the difference between the Completion rate(% of total enrollments) of Burundi in 1984 and the Completion rate(% of total enrollments) of Philippines in 1988?
Your response must be concise. -58.6. What is the difference between the Completion rate(% of total enrollments) in Burundi in 1984 and the Completion rate(% of total enrollments) in Switzerland in 1988?
Offer a terse response. -21.46. What is the difference between the Completion rate(% of total enrollments) of Greece in 1984 and the Completion rate(% of total enrollments) of Philippines in 1988?
Provide a short and direct response. 16.14. What is the difference between the Completion rate(% of total enrollments) in Greece in 1984 and the Completion rate(% of total enrollments) in Switzerland in 1988?
Make the answer very short. 53.29. What is the difference between the Completion rate(% of total enrollments) in Philippines in 1984 and the Completion rate(% of total enrollments) in Switzerland in 1988?
Offer a very short reply. 42.32. What is the difference between the Completion rate(% of total enrollments) in Burundi in 1984 and the Completion rate(% of total enrollments) in Greece in 1989?
Keep it short and to the point. -70.96. What is the difference between the Completion rate(% of total enrollments) of Burundi in 1984 and the Completion rate(% of total enrollments) of Philippines in 1989?
Your answer should be compact. -60.1. What is the difference between the Completion rate(% of total enrollments) in Burundi in 1984 and the Completion rate(% of total enrollments) in Switzerland in 1989?
Your answer should be compact. -22.86. What is the difference between the Completion rate(% of total enrollments) in Greece in 1984 and the Completion rate(% of total enrollments) in Philippines in 1989?
Ensure brevity in your answer.  14.65. What is the difference between the Completion rate(% of total enrollments) of Greece in 1984 and the Completion rate(% of total enrollments) of Switzerland in 1989?
Your answer should be very brief. 51.89. What is the difference between the Completion rate(% of total enrollments) in Philippines in 1984 and the Completion rate(% of total enrollments) in Switzerland in 1989?
Make the answer very short. 40.92. What is the difference between the Completion rate(% of total enrollments) in Burundi in 1985 and the Completion rate(% of total enrollments) in Greece in 1986?
Your answer should be compact. -81.96. What is the difference between the Completion rate(% of total enrollments) in Burundi in 1985 and the Completion rate(% of total enrollments) in Philippines in 1986?
Give a very brief answer. -58.79. What is the difference between the Completion rate(% of total enrollments) of Burundi in 1985 and the Completion rate(% of total enrollments) of Switzerland in 1986?
Offer a very short reply. -21.71. What is the difference between the Completion rate(% of total enrollments) of Greece in 1985 and the Completion rate(% of total enrollments) of Philippines in 1986?
Offer a very short reply. 17.62. What is the difference between the Completion rate(% of total enrollments) of Greece in 1985 and the Completion rate(% of total enrollments) of Switzerland in 1986?
Keep it short and to the point. 54.7. What is the difference between the Completion rate(% of total enrollments) of Philippines in 1985 and the Completion rate(% of total enrollments) of Switzerland in 1986?
Your response must be concise. 39.31. What is the difference between the Completion rate(% of total enrollments) in Burundi in 1985 and the Completion rate(% of total enrollments) in Greece in 1987?
Keep it short and to the point. -72.35. What is the difference between the Completion rate(% of total enrollments) in Burundi in 1985 and the Completion rate(% of total enrollments) in Philippines in 1987?
Provide a succinct answer. -58.09. What is the difference between the Completion rate(% of total enrollments) in Burundi in 1985 and the Completion rate(% of total enrollments) in Switzerland in 1987?
Make the answer very short. -21.27. What is the difference between the Completion rate(% of total enrollments) in Greece in 1985 and the Completion rate(% of total enrollments) in Philippines in 1987?
Your answer should be compact. 18.32. What is the difference between the Completion rate(% of total enrollments) in Greece in 1985 and the Completion rate(% of total enrollments) in Switzerland in 1987?
Provide a short and direct response. 55.14. What is the difference between the Completion rate(% of total enrollments) in Philippines in 1985 and the Completion rate(% of total enrollments) in Switzerland in 1987?
Provide a succinct answer. 39.75. What is the difference between the Completion rate(% of total enrollments) in Burundi in 1985 and the Completion rate(% of total enrollments) in Greece in 1988?
Provide a short and direct response. -72.95. What is the difference between the Completion rate(% of total enrollments) in Burundi in 1985 and the Completion rate(% of total enrollments) in Philippines in 1988?
Your response must be concise. -57.47. What is the difference between the Completion rate(% of total enrollments) of Burundi in 1985 and the Completion rate(% of total enrollments) of Switzerland in 1988?
Give a very brief answer. -20.32. What is the difference between the Completion rate(% of total enrollments) of Greece in 1985 and the Completion rate(% of total enrollments) of Philippines in 1988?
Ensure brevity in your answer.  18.94. What is the difference between the Completion rate(% of total enrollments) in Greece in 1985 and the Completion rate(% of total enrollments) in Switzerland in 1988?
Your answer should be compact. 56.09. What is the difference between the Completion rate(% of total enrollments) of Philippines in 1985 and the Completion rate(% of total enrollments) of Switzerland in 1988?
Provide a succinct answer. 40.69. What is the difference between the Completion rate(% of total enrollments) in Burundi in 1985 and the Completion rate(% of total enrollments) in Greece in 1989?
Your response must be concise. -69.83. What is the difference between the Completion rate(% of total enrollments) of Burundi in 1985 and the Completion rate(% of total enrollments) of Philippines in 1989?
Your response must be concise. -58.96. What is the difference between the Completion rate(% of total enrollments) of Burundi in 1985 and the Completion rate(% of total enrollments) of Switzerland in 1989?
Your response must be concise. -21.72. What is the difference between the Completion rate(% of total enrollments) in Greece in 1985 and the Completion rate(% of total enrollments) in Philippines in 1989?
Offer a very short reply. 17.45. What is the difference between the Completion rate(% of total enrollments) in Greece in 1985 and the Completion rate(% of total enrollments) in Switzerland in 1989?
Your answer should be very brief. 54.69. What is the difference between the Completion rate(% of total enrollments) in Philippines in 1985 and the Completion rate(% of total enrollments) in Switzerland in 1989?
Offer a terse response. 39.29. What is the difference between the Completion rate(% of total enrollments) of Burundi in 1986 and the Completion rate(% of total enrollments) of Greece in 1987?
Keep it short and to the point. -71.4. What is the difference between the Completion rate(% of total enrollments) of Burundi in 1986 and the Completion rate(% of total enrollments) of Philippines in 1987?
Make the answer very short. -57.14. What is the difference between the Completion rate(% of total enrollments) of Burundi in 1986 and the Completion rate(% of total enrollments) of Switzerland in 1987?
Provide a succinct answer. -20.32. What is the difference between the Completion rate(% of total enrollments) in Greece in 1986 and the Completion rate(% of total enrollments) in Philippines in 1987?
Your answer should be compact. 23.87. What is the difference between the Completion rate(% of total enrollments) in Greece in 1986 and the Completion rate(% of total enrollments) in Switzerland in 1987?
Ensure brevity in your answer.  60.69. What is the difference between the Completion rate(% of total enrollments) in Philippines in 1986 and the Completion rate(% of total enrollments) in Switzerland in 1987?
Offer a very short reply. 37.52. What is the difference between the Completion rate(% of total enrollments) of Burundi in 1986 and the Completion rate(% of total enrollments) of Greece in 1988?
Your response must be concise. -72. What is the difference between the Completion rate(% of total enrollments) of Burundi in 1986 and the Completion rate(% of total enrollments) of Philippines in 1988?
Keep it short and to the point. -56.52. What is the difference between the Completion rate(% of total enrollments) of Burundi in 1986 and the Completion rate(% of total enrollments) of Switzerland in 1988?
Offer a terse response. -19.38. What is the difference between the Completion rate(% of total enrollments) of Greece in 1986 and the Completion rate(% of total enrollments) of Philippines in 1988?
Make the answer very short. 24.5. What is the difference between the Completion rate(% of total enrollments) in Greece in 1986 and the Completion rate(% of total enrollments) in Switzerland in 1988?
Offer a very short reply. 61.64. What is the difference between the Completion rate(% of total enrollments) in Philippines in 1986 and the Completion rate(% of total enrollments) in Switzerland in 1988?
Your response must be concise. 38.46. What is the difference between the Completion rate(% of total enrollments) in Burundi in 1986 and the Completion rate(% of total enrollments) in Greece in 1989?
Provide a succinct answer. -68.88. What is the difference between the Completion rate(% of total enrollments) of Burundi in 1986 and the Completion rate(% of total enrollments) of Philippines in 1989?
Offer a terse response. -58.02. What is the difference between the Completion rate(% of total enrollments) in Burundi in 1986 and the Completion rate(% of total enrollments) in Switzerland in 1989?
Offer a very short reply. -20.78. What is the difference between the Completion rate(% of total enrollments) in Greece in 1986 and the Completion rate(% of total enrollments) in Philippines in 1989?
Keep it short and to the point. 23. What is the difference between the Completion rate(% of total enrollments) of Greece in 1986 and the Completion rate(% of total enrollments) of Switzerland in 1989?
Ensure brevity in your answer.  60.24. What is the difference between the Completion rate(% of total enrollments) in Philippines in 1986 and the Completion rate(% of total enrollments) in Switzerland in 1989?
Provide a succinct answer. 37.06. What is the difference between the Completion rate(% of total enrollments) in Burundi in 1987 and the Completion rate(% of total enrollments) in Greece in 1988?
Provide a succinct answer. -72.58. What is the difference between the Completion rate(% of total enrollments) of Burundi in 1987 and the Completion rate(% of total enrollments) of Philippines in 1988?
Give a very brief answer. -57.1. What is the difference between the Completion rate(% of total enrollments) of Burundi in 1987 and the Completion rate(% of total enrollments) of Switzerland in 1988?
Make the answer very short. -19.96. What is the difference between the Completion rate(% of total enrollments) in Greece in 1987 and the Completion rate(% of total enrollments) in Philippines in 1988?
Ensure brevity in your answer.  14.88. What is the difference between the Completion rate(% of total enrollments) in Greece in 1987 and the Completion rate(% of total enrollments) in Switzerland in 1988?
Offer a terse response. 52.02. What is the difference between the Completion rate(% of total enrollments) in Philippines in 1987 and the Completion rate(% of total enrollments) in Switzerland in 1988?
Keep it short and to the point. 37.77. What is the difference between the Completion rate(% of total enrollments) in Burundi in 1987 and the Completion rate(% of total enrollments) in Greece in 1989?
Ensure brevity in your answer.  -69.46. What is the difference between the Completion rate(% of total enrollments) in Burundi in 1987 and the Completion rate(% of total enrollments) in Philippines in 1989?
Provide a succinct answer. -58.6. What is the difference between the Completion rate(% of total enrollments) of Burundi in 1987 and the Completion rate(% of total enrollments) of Switzerland in 1989?
Your response must be concise. -21.36. What is the difference between the Completion rate(% of total enrollments) in Greece in 1987 and the Completion rate(% of total enrollments) in Philippines in 1989?
Ensure brevity in your answer.  13.38. What is the difference between the Completion rate(% of total enrollments) of Greece in 1987 and the Completion rate(% of total enrollments) of Switzerland in 1989?
Provide a succinct answer. 50.62. What is the difference between the Completion rate(% of total enrollments) of Philippines in 1987 and the Completion rate(% of total enrollments) of Switzerland in 1989?
Give a very brief answer. 36.37. What is the difference between the Completion rate(% of total enrollments) of Burundi in 1988 and the Completion rate(% of total enrollments) of Greece in 1989?
Your answer should be compact. -58.9. What is the difference between the Completion rate(% of total enrollments) of Burundi in 1988 and the Completion rate(% of total enrollments) of Philippines in 1989?
Provide a short and direct response. -48.03. What is the difference between the Completion rate(% of total enrollments) in Burundi in 1988 and the Completion rate(% of total enrollments) in Switzerland in 1989?
Make the answer very short. -10.79. What is the difference between the Completion rate(% of total enrollments) of Greece in 1988 and the Completion rate(% of total enrollments) of Philippines in 1989?
Your response must be concise. 13.99. What is the difference between the Completion rate(% of total enrollments) in Greece in 1988 and the Completion rate(% of total enrollments) in Switzerland in 1989?
Your answer should be very brief. 51.23. What is the difference between the Completion rate(% of total enrollments) of Philippines in 1988 and the Completion rate(% of total enrollments) of Switzerland in 1989?
Keep it short and to the point. 35.74. What is the average Completion rate(% of total enrollments) of Burundi per year?
Ensure brevity in your answer.  27.08. What is the average Completion rate(% of total enrollments) in Greece per year?
Your response must be concise. 101.5. What is the average Completion rate(% of total enrollments) in Philippines per year?
Provide a succinct answer. 87.7. What is the average Completion rate(% of total enrollments) in Switzerland per year?
Ensure brevity in your answer.  50.44. In the year 1981, what is the difference between the Completion rate(% of total enrollments) in Burundi and Completion rate(% of total enrollments) in Greece?
Provide a short and direct response. -85.14. In the year 1981, what is the difference between the Completion rate(% of total enrollments) in Burundi and Completion rate(% of total enrollments) in Philippines?
Your answer should be compact. -73.66. In the year 1981, what is the difference between the Completion rate(% of total enrollments) in Burundi and Completion rate(% of total enrollments) in Switzerland?
Your answer should be compact. -39.9. In the year 1981, what is the difference between the Completion rate(% of total enrollments) in Greece and Completion rate(% of total enrollments) in Philippines?
Your answer should be compact. 11.48. In the year 1981, what is the difference between the Completion rate(% of total enrollments) of Greece and Completion rate(% of total enrollments) of Switzerland?
Provide a succinct answer. 45.24. In the year 1981, what is the difference between the Completion rate(% of total enrollments) in Philippines and Completion rate(% of total enrollments) in Switzerland?
Offer a very short reply. 33.76. In the year 1983, what is the difference between the Completion rate(% of total enrollments) of Burundi and Completion rate(% of total enrollments) of Greece?
Ensure brevity in your answer.  -79.07. In the year 1983, what is the difference between the Completion rate(% of total enrollments) in Burundi and Completion rate(% of total enrollments) in Philippines?
Provide a short and direct response. -70.32. In the year 1983, what is the difference between the Completion rate(% of total enrollments) in Burundi and Completion rate(% of total enrollments) in Switzerland?
Provide a short and direct response. -32.32. In the year 1983, what is the difference between the Completion rate(% of total enrollments) in Greece and Completion rate(% of total enrollments) in Philippines?
Offer a very short reply. 8.75. In the year 1983, what is the difference between the Completion rate(% of total enrollments) in Greece and Completion rate(% of total enrollments) in Switzerland?
Offer a terse response. 46.76. In the year 1983, what is the difference between the Completion rate(% of total enrollments) of Philippines and Completion rate(% of total enrollments) of Switzerland?
Offer a terse response. 38.01. In the year 1984, what is the difference between the Completion rate(% of total enrollments) of Burundi and Completion rate(% of total enrollments) of Greece?
Your answer should be compact. -74.74. In the year 1984, what is the difference between the Completion rate(% of total enrollments) in Burundi and Completion rate(% of total enrollments) in Philippines?
Provide a succinct answer. -63.77. In the year 1984, what is the difference between the Completion rate(% of total enrollments) of Burundi and Completion rate(% of total enrollments) of Switzerland?
Ensure brevity in your answer.  -24.19. In the year 1984, what is the difference between the Completion rate(% of total enrollments) in Greece and Completion rate(% of total enrollments) in Philippines?
Your response must be concise. 10.97. In the year 1984, what is the difference between the Completion rate(% of total enrollments) of Greece and Completion rate(% of total enrollments) of Switzerland?
Your response must be concise. 50.55. In the year 1984, what is the difference between the Completion rate(% of total enrollments) in Philippines and Completion rate(% of total enrollments) in Switzerland?
Offer a very short reply. 39.58. In the year 1985, what is the difference between the Completion rate(% of total enrollments) in Burundi and Completion rate(% of total enrollments) in Greece?
Your answer should be very brief. -76.41. In the year 1985, what is the difference between the Completion rate(% of total enrollments) of Burundi and Completion rate(% of total enrollments) of Philippines?
Your answer should be compact. -61.02. In the year 1985, what is the difference between the Completion rate(% of total enrollments) of Burundi and Completion rate(% of total enrollments) of Switzerland?
Keep it short and to the point. -22.55. In the year 1985, what is the difference between the Completion rate(% of total enrollments) of Greece and Completion rate(% of total enrollments) of Philippines?
Provide a succinct answer. 15.39. In the year 1985, what is the difference between the Completion rate(% of total enrollments) of Greece and Completion rate(% of total enrollments) of Switzerland?
Offer a very short reply. 53.86. In the year 1985, what is the difference between the Completion rate(% of total enrollments) of Philippines and Completion rate(% of total enrollments) of Switzerland?
Your answer should be very brief. 38.47. In the year 1986, what is the difference between the Completion rate(% of total enrollments) of Burundi and Completion rate(% of total enrollments) of Greece?
Provide a short and direct response. -81.02. In the year 1986, what is the difference between the Completion rate(% of total enrollments) of Burundi and Completion rate(% of total enrollments) of Philippines?
Keep it short and to the point. -57.84. In the year 1986, what is the difference between the Completion rate(% of total enrollments) of Burundi and Completion rate(% of total enrollments) of Switzerland?
Your answer should be compact. -20.76. In the year 1986, what is the difference between the Completion rate(% of total enrollments) in Greece and Completion rate(% of total enrollments) in Philippines?
Provide a succinct answer. 23.18. In the year 1986, what is the difference between the Completion rate(% of total enrollments) of Greece and Completion rate(% of total enrollments) of Switzerland?
Provide a succinct answer. 60.26. In the year 1986, what is the difference between the Completion rate(% of total enrollments) in Philippines and Completion rate(% of total enrollments) in Switzerland?
Provide a short and direct response. 37.08. In the year 1987, what is the difference between the Completion rate(% of total enrollments) in Burundi and Completion rate(% of total enrollments) in Greece?
Provide a short and direct response. -71.98. In the year 1987, what is the difference between the Completion rate(% of total enrollments) of Burundi and Completion rate(% of total enrollments) of Philippines?
Make the answer very short. -57.72. In the year 1987, what is the difference between the Completion rate(% of total enrollments) of Burundi and Completion rate(% of total enrollments) of Switzerland?
Ensure brevity in your answer.  -20.9. In the year 1987, what is the difference between the Completion rate(% of total enrollments) of Greece and Completion rate(% of total enrollments) of Philippines?
Your answer should be compact. 14.26. In the year 1987, what is the difference between the Completion rate(% of total enrollments) of Greece and Completion rate(% of total enrollments) of Switzerland?
Make the answer very short. 51.08. In the year 1987, what is the difference between the Completion rate(% of total enrollments) in Philippines and Completion rate(% of total enrollments) in Switzerland?
Ensure brevity in your answer.  36.82. In the year 1988, what is the difference between the Completion rate(% of total enrollments) in Burundi and Completion rate(% of total enrollments) in Greece?
Your answer should be very brief. -62.02. In the year 1988, what is the difference between the Completion rate(% of total enrollments) of Burundi and Completion rate(% of total enrollments) of Philippines?
Make the answer very short. -46.54. In the year 1988, what is the difference between the Completion rate(% of total enrollments) in Burundi and Completion rate(% of total enrollments) in Switzerland?
Your answer should be very brief. -9.39. In the year 1988, what is the difference between the Completion rate(% of total enrollments) of Greece and Completion rate(% of total enrollments) of Philippines?
Your answer should be very brief. 15.48. In the year 1988, what is the difference between the Completion rate(% of total enrollments) of Greece and Completion rate(% of total enrollments) of Switzerland?
Your response must be concise. 52.63. In the year 1988, what is the difference between the Completion rate(% of total enrollments) in Philippines and Completion rate(% of total enrollments) in Switzerland?
Provide a short and direct response. 37.14. In the year 1989, what is the difference between the Completion rate(% of total enrollments) of Burundi and Completion rate(% of total enrollments) of Greece?
Provide a succinct answer. -64.99. In the year 1989, what is the difference between the Completion rate(% of total enrollments) in Burundi and Completion rate(% of total enrollments) in Philippines?
Ensure brevity in your answer.  -54.13. In the year 1989, what is the difference between the Completion rate(% of total enrollments) of Burundi and Completion rate(% of total enrollments) of Switzerland?
Give a very brief answer. -16.89. In the year 1989, what is the difference between the Completion rate(% of total enrollments) in Greece and Completion rate(% of total enrollments) in Philippines?
Give a very brief answer. 10.87. In the year 1989, what is the difference between the Completion rate(% of total enrollments) in Greece and Completion rate(% of total enrollments) in Switzerland?
Offer a terse response. 48.11. In the year 1989, what is the difference between the Completion rate(% of total enrollments) of Philippines and Completion rate(% of total enrollments) of Switzerland?
Provide a short and direct response. 37.24. What is the ratio of the Completion rate(% of total enrollments) in Burundi in 1981 to that in 1983?
Your answer should be very brief. 0.61. What is the ratio of the Completion rate(% of total enrollments) of Greece in 1981 to that in 1983?
Your answer should be compact. 0.98. What is the ratio of the Completion rate(% of total enrollments) in Philippines in 1981 to that in 1983?
Keep it short and to the point. 0.95. What is the ratio of the Completion rate(% of total enrollments) in Switzerland in 1981 to that in 1983?
Offer a terse response. 1. What is the ratio of the Completion rate(% of total enrollments) of Burundi in 1981 to that in 1984?
Offer a very short reply. 0.45. What is the ratio of the Completion rate(% of total enrollments) of Greece in 1981 to that in 1984?
Provide a short and direct response. 0.96. What is the ratio of the Completion rate(% of total enrollments) in Philippines in 1981 to that in 1984?
Give a very brief answer. 0.94. What is the ratio of the Completion rate(% of total enrollments) in Switzerland in 1981 to that in 1984?
Your answer should be compact. 1.02. What is the ratio of the Completion rate(% of total enrollments) of Burundi in 1981 to that in 1985?
Provide a short and direct response. 0.43. What is the ratio of the Completion rate(% of total enrollments) of Greece in 1981 to that in 1985?
Provide a succinct answer. 0.93. What is the ratio of the Completion rate(% of total enrollments) of Philippines in 1981 to that in 1985?
Ensure brevity in your answer.  0.96. What is the ratio of the Completion rate(% of total enrollments) in Switzerland in 1981 to that in 1985?
Make the answer very short. 1.03. What is the ratio of the Completion rate(% of total enrollments) of Burundi in 1981 to that in 1986?
Keep it short and to the point. 0.42. What is the ratio of the Completion rate(% of total enrollments) in Greece in 1981 to that in 1986?
Ensure brevity in your answer.  0.88. What is the ratio of the Completion rate(% of total enrollments) of Philippines in 1981 to that in 1986?
Ensure brevity in your answer.  0.99. What is the ratio of the Completion rate(% of total enrollments) of Switzerland in 1981 to that in 1986?
Ensure brevity in your answer.  1.04. What is the ratio of the Completion rate(% of total enrollments) of Burundi in 1981 to that in 1987?
Provide a short and direct response. 0.42. What is the ratio of the Completion rate(% of total enrollments) in Greece in 1981 to that in 1987?
Give a very brief answer. 0.97. What is the ratio of the Completion rate(% of total enrollments) in Philippines in 1981 to that in 1987?
Offer a terse response. 0.99. What is the ratio of the Completion rate(% of total enrollments) of Switzerland in 1981 to that in 1987?
Give a very brief answer. 1.05. What is the ratio of the Completion rate(% of total enrollments) in Burundi in 1981 to that in 1988?
Provide a short and direct response. 0.31. What is the ratio of the Completion rate(% of total enrollments) in Greece in 1981 to that in 1988?
Keep it short and to the point. 0.96. What is the ratio of the Completion rate(% of total enrollments) of Switzerland in 1981 to that in 1988?
Offer a very short reply. 1.07. What is the ratio of the Completion rate(% of total enrollments) in Burundi in 1981 to that in 1989?
Make the answer very short. 0.37. What is the ratio of the Completion rate(% of total enrollments) in Greece in 1981 to that in 1989?
Your answer should be compact. 0.99. What is the ratio of the Completion rate(% of total enrollments) in Philippines in 1981 to that in 1989?
Provide a short and direct response. 0.98. What is the ratio of the Completion rate(% of total enrollments) of Switzerland in 1981 to that in 1989?
Offer a terse response. 1.04. What is the ratio of the Completion rate(% of total enrollments) of Burundi in 1983 to that in 1984?
Your response must be concise. 0.73. What is the ratio of the Completion rate(% of total enrollments) in Greece in 1983 to that in 1984?
Your answer should be very brief. 0.97. What is the ratio of the Completion rate(% of total enrollments) in Switzerland in 1983 to that in 1984?
Your answer should be very brief. 1.02. What is the ratio of the Completion rate(% of total enrollments) of Burundi in 1983 to that in 1985?
Provide a short and direct response. 0.7. What is the ratio of the Completion rate(% of total enrollments) in Greece in 1983 to that in 1985?
Offer a terse response. 0.94. What is the ratio of the Completion rate(% of total enrollments) in Philippines in 1983 to that in 1985?
Keep it short and to the point. 1.01. What is the ratio of the Completion rate(% of total enrollments) in Switzerland in 1983 to that in 1985?
Offer a very short reply. 1.03. What is the ratio of the Completion rate(% of total enrollments) of Burundi in 1983 to that in 1986?
Ensure brevity in your answer.  0.68. What is the ratio of the Completion rate(% of total enrollments) in Greece in 1983 to that in 1986?
Give a very brief answer. 0.9. What is the ratio of the Completion rate(% of total enrollments) in Philippines in 1983 to that in 1986?
Offer a terse response. 1.04. What is the ratio of the Completion rate(% of total enrollments) of Switzerland in 1983 to that in 1986?
Keep it short and to the point. 1.04. What is the ratio of the Completion rate(% of total enrollments) of Burundi in 1983 to that in 1987?
Make the answer very short. 0.69. What is the ratio of the Completion rate(% of total enrollments) of Greece in 1983 to that in 1987?
Provide a succinct answer. 0.98. What is the ratio of the Completion rate(% of total enrollments) in Philippines in 1983 to that in 1987?
Offer a very short reply. 1.04. What is the ratio of the Completion rate(% of total enrollments) in Switzerland in 1983 to that in 1987?
Ensure brevity in your answer.  1.05. What is the ratio of the Completion rate(% of total enrollments) of Burundi in 1983 to that in 1988?
Provide a short and direct response. 0.5. What is the ratio of the Completion rate(% of total enrollments) in Greece in 1983 to that in 1988?
Keep it short and to the point. 0.98. What is the ratio of the Completion rate(% of total enrollments) of Philippines in 1983 to that in 1988?
Provide a succinct answer. 1.05. What is the ratio of the Completion rate(% of total enrollments) in Switzerland in 1983 to that in 1988?
Your response must be concise. 1.07. What is the ratio of the Completion rate(% of total enrollments) of Burundi in 1983 to that in 1989?
Ensure brevity in your answer.  0.6. What is the ratio of the Completion rate(% of total enrollments) of Greece in 1983 to that in 1989?
Provide a short and direct response. 1.01. What is the ratio of the Completion rate(% of total enrollments) of Philippines in 1983 to that in 1989?
Ensure brevity in your answer.  1.03. What is the ratio of the Completion rate(% of total enrollments) of Switzerland in 1983 to that in 1989?
Your response must be concise. 1.04. What is the ratio of the Completion rate(% of total enrollments) in Burundi in 1984 to that in 1985?
Keep it short and to the point. 0.96. What is the ratio of the Completion rate(% of total enrollments) in Greece in 1984 to that in 1985?
Keep it short and to the point. 0.97. What is the ratio of the Completion rate(% of total enrollments) of Philippines in 1984 to that in 1985?
Offer a very short reply. 1.02. What is the ratio of the Completion rate(% of total enrollments) in Switzerland in 1984 to that in 1985?
Your answer should be very brief. 1.01. What is the ratio of the Completion rate(% of total enrollments) in Burundi in 1984 to that in 1986?
Give a very brief answer. 0.93. What is the ratio of the Completion rate(% of total enrollments) of Greece in 1984 to that in 1986?
Ensure brevity in your answer.  0.92. What is the ratio of the Completion rate(% of total enrollments) of Philippines in 1984 to that in 1986?
Offer a very short reply. 1.04. What is the ratio of the Completion rate(% of total enrollments) of Switzerland in 1984 to that in 1986?
Your answer should be very brief. 1.03. What is the ratio of the Completion rate(% of total enrollments) of Burundi in 1984 to that in 1987?
Make the answer very short. 0.95. What is the ratio of the Completion rate(% of total enrollments) in Greece in 1984 to that in 1987?
Make the answer very short. 1.01. What is the ratio of the Completion rate(% of total enrollments) of Philippines in 1984 to that in 1987?
Provide a succinct answer. 1.05. What is the ratio of the Completion rate(% of total enrollments) of Switzerland in 1984 to that in 1987?
Provide a succinct answer. 1.04. What is the ratio of the Completion rate(% of total enrollments) of Burundi in 1984 to that in 1988?
Make the answer very short. 0.69. What is the ratio of the Completion rate(% of total enrollments) of Greece in 1984 to that in 1988?
Your answer should be compact. 1.01. What is the ratio of the Completion rate(% of total enrollments) in Philippines in 1984 to that in 1988?
Give a very brief answer. 1.06. What is the ratio of the Completion rate(% of total enrollments) of Switzerland in 1984 to that in 1988?
Your answer should be very brief. 1.06. What is the ratio of the Completion rate(% of total enrollments) of Burundi in 1984 to that in 1989?
Your answer should be compact. 0.82. What is the ratio of the Completion rate(% of total enrollments) of Greece in 1984 to that in 1989?
Offer a terse response. 1.04. What is the ratio of the Completion rate(% of total enrollments) in Philippines in 1984 to that in 1989?
Your answer should be very brief. 1.04. What is the ratio of the Completion rate(% of total enrollments) in Switzerland in 1984 to that in 1989?
Your answer should be compact. 1.03. What is the ratio of the Completion rate(% of total enrollments) of Burundi in 1985 to that in 1986?
Your response must be concise. 0.97. What is the ratio of the Completion rate(% of total enrollments) in Greece in 1985 to that in 1986?
Provide a short and direct response. 0.95. What is the ratio of the Completion rate(% of total enrollments) in Philippines in 1985 to that in 1986?
Your answer should be compact. 1.03. What is the ratio of the Completion rate(% of total enrollments) in Switzerland in 1985 to that in 1986?
Provide a short and direct response. 1.02. What is the ratio of the Completion rate(% of total enrollments) in Burundi in 1985 to that in 1987?
Ensure brevity in your answer.  0.99. What is the ratio of the Completion rate(% of total enrollments) of Greece in 1985 to that in 1987?
Offer a very short reply. 1.04. What is the ratio of the Completion rate(% of total enrollments) in Philippines in 1985 to that in 1987?
Your answer should be compact. 1.03. What is the ratio of the Completion rate(% of total enrollments) in Switzerland in 1985 to that in 1987?
Offer a very short reply. 1.03. What is the ratio of the Completion rate(% of total enrollments) of Burundi in 1985 to that in 1988?
Your answer should be compact. 0.72. What is the ratio of the Completion rate(% of total enrollments) of Greece in 1985 to that in 1988?
Provide a succinct answer. 1.03. What is the ratio of the Completion rate(% of total enrollments) of Philippines in 1985 to that in 1988?
Provide a short and direct response. 1.04. What is the ratio of the Completion rate(% of total enrollments) of Switzerland in 1985 to that in 1988?
Ensure brevity in your answer.  1.05. What is the ratio of the Completion rate(% of total enrollments) of Burundi in 1985 to that in 1989?
Keep it short and to the point. 0.85. What is the ratio of the Completion rate(% of total enrollments) of Greece in 1985 to that in 1989?
Make the answer very short. 1.07. What is the ratio of the Completion rate(% of total enrollments) of Philippines in 1985 to that in 1989?
Keep it short and to the point. 1.02. What is the ratio of the Completion rate(% of total enrollments) of Switzerland in 1985 to that in 1989?
Your answer should be very brief. 1.02. What is the ratio of the Completion rate(% of total enrollments) in Burundi in 1986 to that in 1987?
Provide a succinct answer. 1.02. What is the ratio of the Completion rate(% of total enrollments) of Greece in 1986 to that in 1987?
Make the answer very short. 1.1. What is the ratio of the Completion rate(% of total enrollments) in Philippines in 1986 to that in 1987?
Give a very brief answer. 1.01. What is the ratio of the Completion rate(% of total enrollments) in Switzerland in 1986 to that in 1987?
Give a very brief answer. 1.01. What is the ratio of the Completion rate(% of total enrollments) of Burundi in 1986 to that in 1988?
Keep it short and to the point. 0.74. What is the ratio of the Completion rate(% of total enrollments) of Greece in 1986 to that in 1988?
Make the answer very short. 1.09. What is the ratio of the Completion rate(% of total enrollments) in Philippines in 1986 to that in 1988?
Keep it short and to the point. 1.02. What is the ratio of the Completion rate(% of total enrollments) in Switzerland in 1986 to that in 1988?
Your answer should be compact. 1.03. What is the ratio of the Completion rate(% of total enrollments) in Burundi in 1986 to that in 1989?
Provide a short and direct response. 0.88. What is the ratio of the Completion rate(% of total enrollments) in Greece in 1986 to that in 1989?
Keep it short and to the point. 1.12. What is the ratio of the Completion rate(% of total enrollments) of Philippines in 1986 to that in 1989?
Your answer should be very brief. 1. What is the ratio of the Completion rate(% of total enrollments) in Burundi in 1987 to that in 1988?
Your response must be concise. 0.73. What is the ratio of the Completion rate(% of total enrollments) in Philippines in 1987 to that in 1988?
Provide a succinct answer. 1.01. What is the ratio of the Completion rate(% of total enrollments) of Switzerland in 1987 to that in 1988?
Offer a very short reply. 1.02. What is the ratio of the Completion rate(% of total enrollments) of Burundi in 1987 to that in 1989?
Make the answer very short. 0.86. What is the ratio of the Completion rate(% of total enrollments) in Greece in 1987 to that in 1989?
Your answer should be very brief. 1.03. What is the ratio of the Completion rate(% of total enrollments) of Switzerland in 1987 to that in 1989?
Your response must be concise. 0.99. What is the ratio of the Completion rate(% of total enrollments) in Burundi in 1988 to that in 1989?
Your answer should be compact. 1.18. What is the ratio of the Completion rate(% of total enrollments) in Greece in 1988 to that in 1989?
Provide a succinct answer. 1.03. What is the ratio of the Completion rate(% of total enrollments) in Philippines in 1988 to that in 1989?
Your answer should be compact. 0.98. What is the ratio of the Completion rate(% of total enrollments) of Switzerland in 1988 to that in 1989?
Your answer should be compact. 0.97. What is the difference between the highest and the second highest Completion rate(% of total enrollments) of Burundi?
Give a very brief answer. 6.09. What is the difference between the highest and the second highest Completion rate(% of total enrollments) of Greece?
Your answer should be very brief. 5.55. What is the difference between the highest and the second highest Completion rate(% of total enrollments) in Philippines?
Ensure brevity in your answer.  0.74. What is the difference between the highest and the second highest Completion rate(% of total enrollments) of Switzerland?
Your answer should be compact. 0.04. What is the difference between the highest and the lowest Completion rate(% of total enrollments) of Burundi?
Your answer should be very brief. 26.98. What is the difference between the highest and the lowest Completion rate(% of total enrollments) of Greece?
Your answer should be very brief. 12.88. What is the difference between the highest and the lowest Completion rate(% of total enrollments) of Philippines?
Provide a short and direct response. 5.17. What is the difference between the highest and the lowest Completion rate(% of total enrollments) of Switzerland?
Provide a short and direct response. 3.57. 